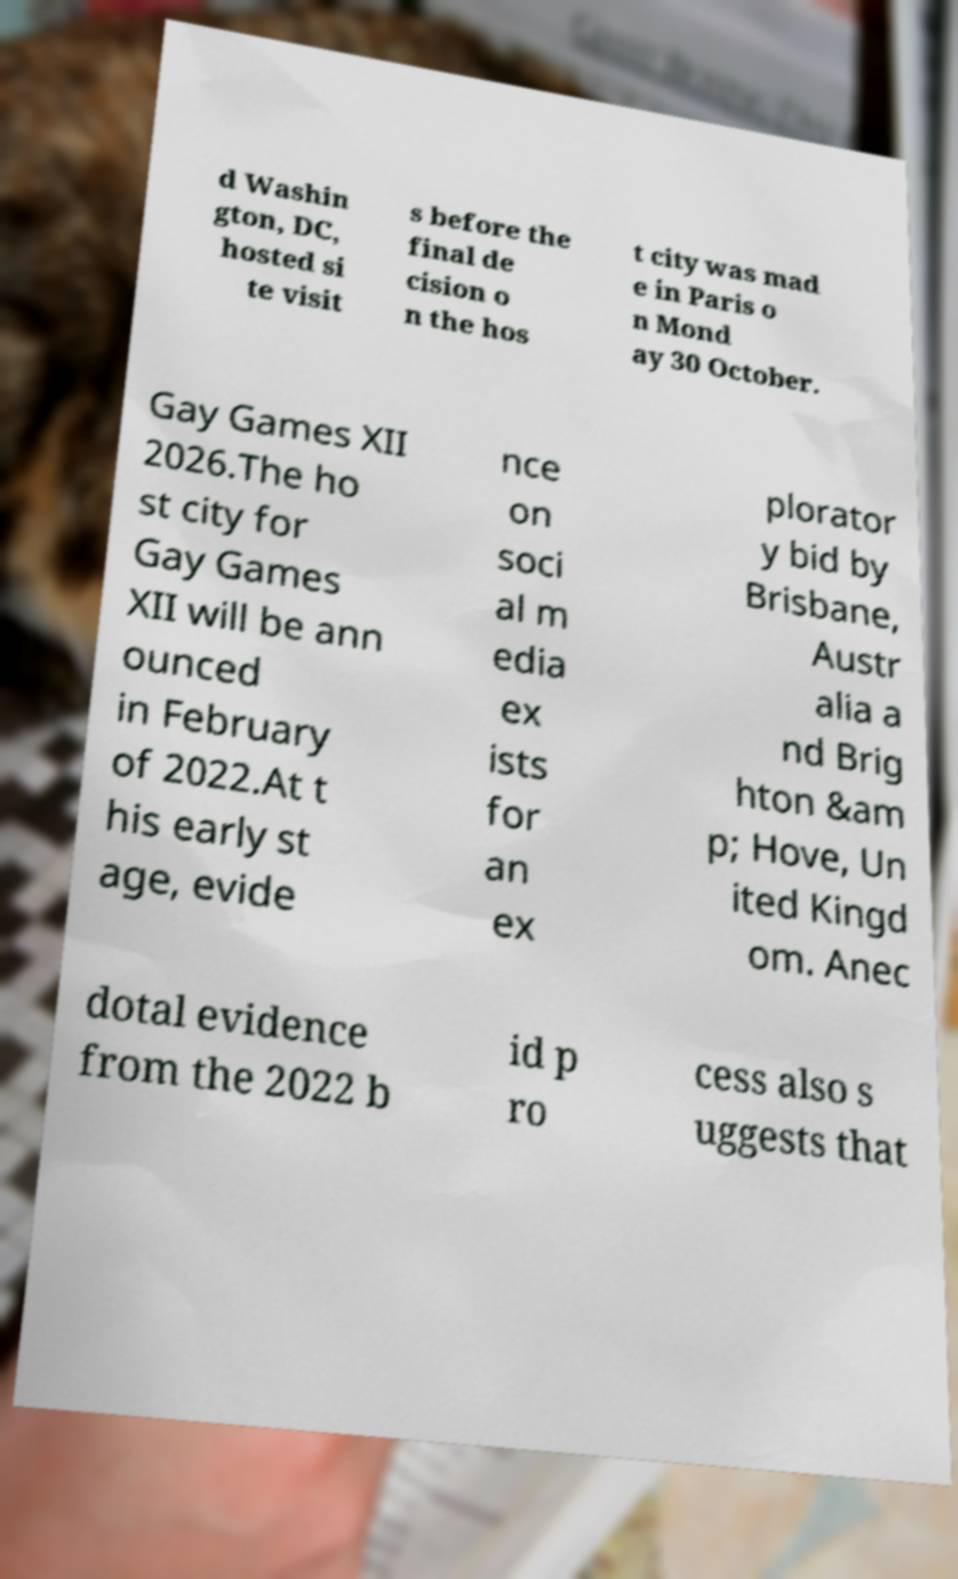Can you read and provide the text displayed in the image?This photo seems to have some interesting text. Can you extract and type it out for me? d Washin gton, DC, hosted si te visit s before the final de cision o n the hos t city was mad e in Paris o n Mond ay 30 October. Gay Games XII 2026.The ho st city for Gay Games XII will be ann ounced in February of 2022.At t his early st age, evide nce on soci al m edia ex ists for an ex plorator y bid by Brisbane, Austr alia a nd Brig hton &am p; Hove, Un ited Kingd om. Anec dotal evidence from the 2022 b id p ro cess also s uggests that 